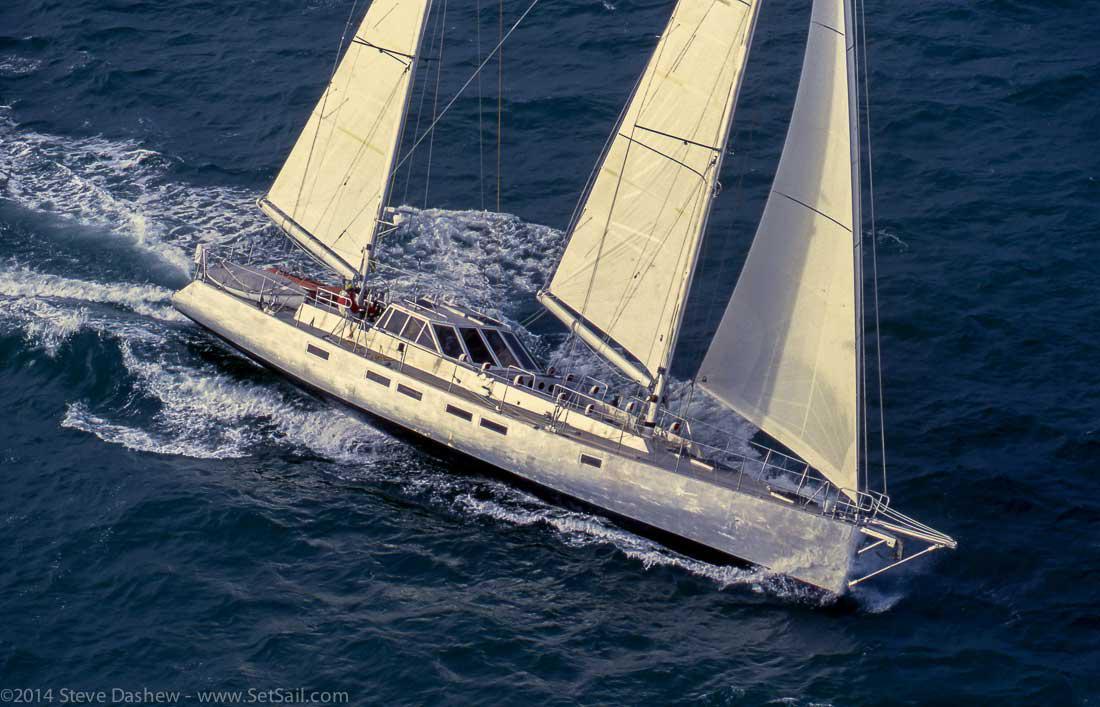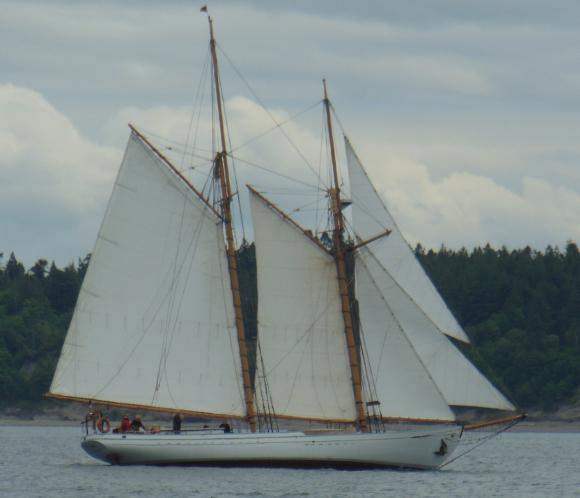The first image is the image on the left, the second image is the image on the right. Analyze the images presented: Is the assertion "The boat in the right image has exactly four sails." valid? Answer yes or no. No. The first image is the image on the left, the second image is the image on the right. Considering the images on both sides, is "The left and right image contains a total of seven open sails." valid? Answer yes or no. No. 